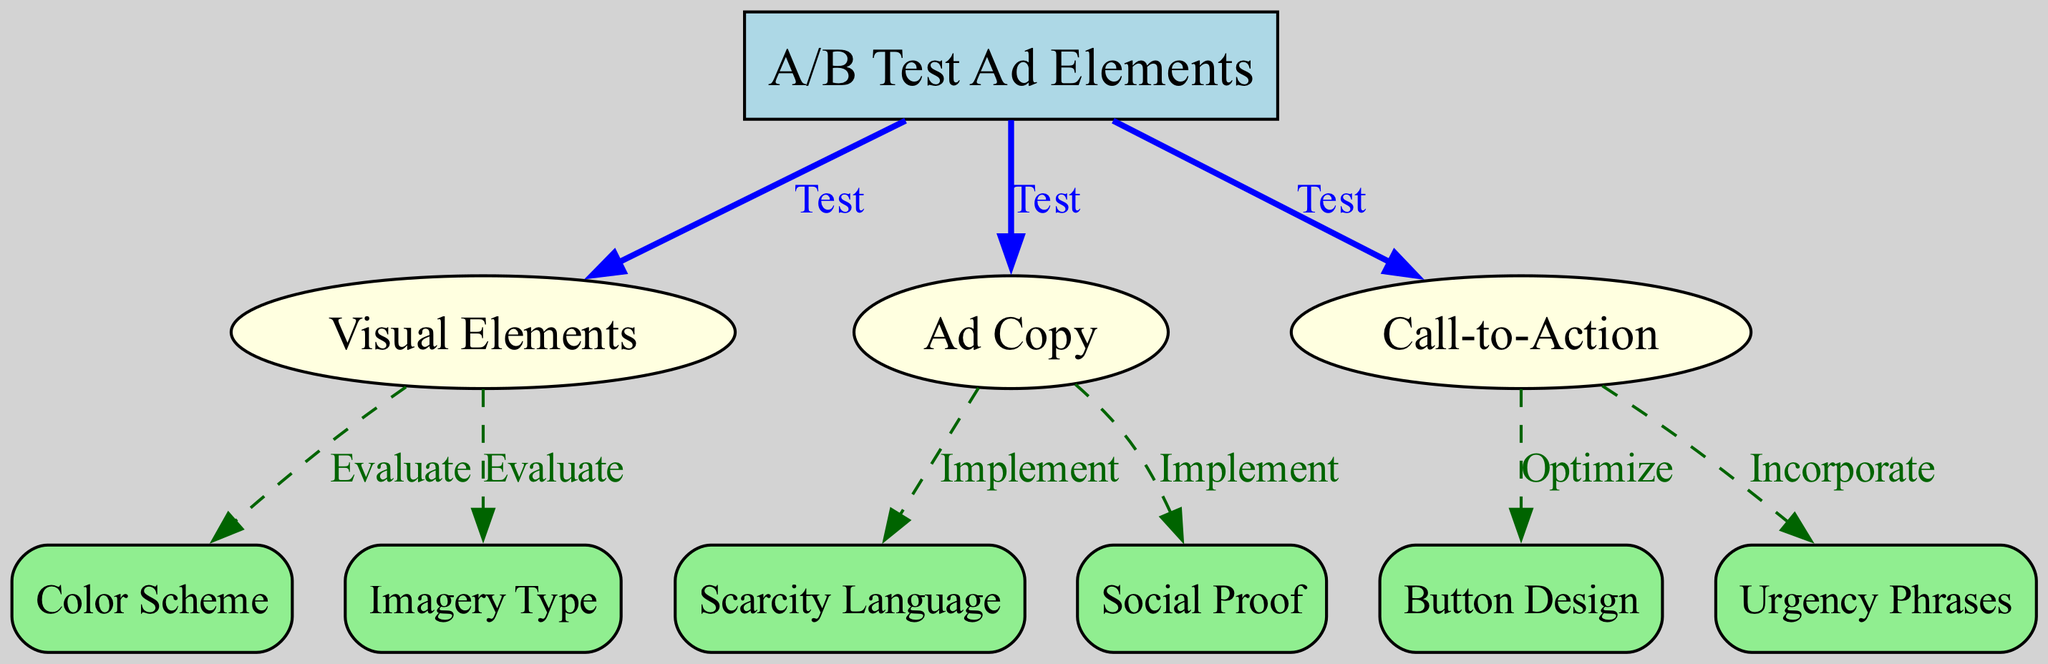What is the main purpose of the diagram? The main purpose of the diagram is to outline a decision tree for A/B testing various ad elements based on psychological triggers. It visually represents the elements involved in the testing process and their relationships.
Answer: A/B Test Ad Elements How many main categories of ad elements are tested? The diagram presents three main categories of ad elements that are tested: Visual Elements, Ad Copy, and Call-to-Action. Each category has specific aspects associated with it.
Answer: 3 What type of edges connect the root to its children nodes? The edges connecting the root node to the children nodes (Visual Elements, Ad Copy, and Call-to-Action) are labeled as "Test", indicating that these elements are being tested during the A/B testing process.
Answer: Test Which element is evaluated under Visual Elements? Two elements are evaluated under Visual Elements: Color Scheme and Imagery Type. These elements are tested to assess their effectiveness in the ad's visual appeal.
Answer: Color Scheme, Imagery Type What action is taken for Copy in this diagram? For Ad Copy, the implemented actions are Scarcity Language and Social Proof, indicating that these psychological triggers are incorporated into the ad copy during the A/B testing process.
Answer: Implement What edge type is used between Copy and its associated elements? The edges between Copy and its associated elements (Scarcity Language and Social Proof) are labeled as "Implement", showing the intention of applying these psychological triggers in the ad copy.
Answer: Implement Which psychological triggers are associated with the Call-to-Action? The psychological triggers associated with Call-to-Action are Button Design and Urgency Phrases, indicating these attributes are essential in optimizing user engagement.
Answer: Button Design, Urgency Phrases If you want to evaluate the usability of a color scheme, from which node would you start? To evaluate the usability of a color scheme, you would start from the Visual Elements node, which further links to the Color Scheme node for evaluation.
Answer: Visual Elements What kind of relationship exists between Visual Elements and its components? The relationship between Visual Elements and its components (Color Scheme and Imagery Type) is described by the edges labeled "Evaluate", indicating that these components are assessed for effectiveness.
Answer: Evaluate 